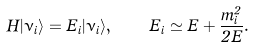<formula> <loc_0><loc_0><loc_500><loc_500>H | \nu _ { i } \rangle = E _ { i } | \nu _ { i } \rangle , \quad E _ { i } \simeq E + \frac { m ^ { 2 } _ { i } } { 2 E } .</formula> 